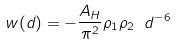<formula> <loc_0><loc_0><loc_500><loc_500>w ( d ) = - \frac { A _ { H } } { \pi ^ { 2 } } \rho _ { 1 } \rho _ { 2 } \ d ^ { - 6 }</formula> 